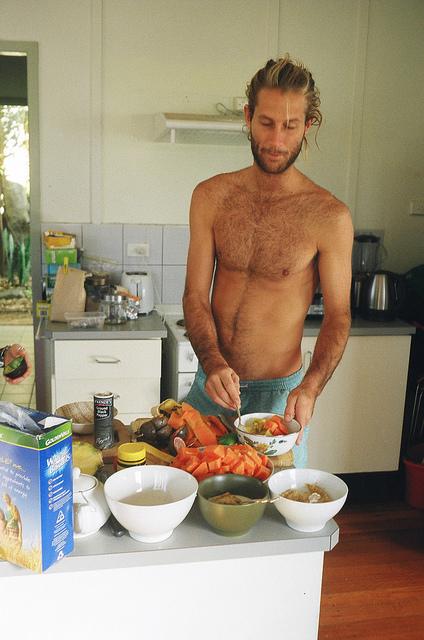What is the man doing?
Concise answer only. Cooking. How many bowls are there?
Keep it brief. 4. Is the man wearing a shirt?
Keep it brief. No. 